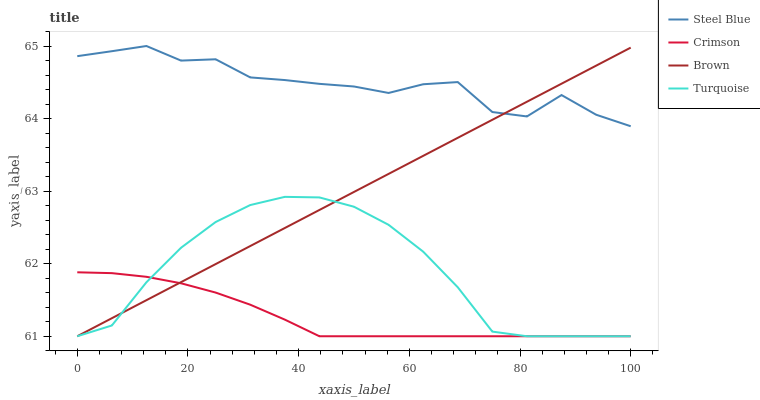Does Crimson have the minimum area under the curve?
Answer yes or no. Yes. Does Steel Blue have the maximum area under the curve?
Answer yes or no. Yes. Does Brown have the minimum area under the curve?
Answer yes or no. No. Does Brown have the maximum area under the curve?
Answer yes or no. No. Is Brown the smoothest?
Answer yes or no. Yes. Is Steel Blue the roughest?
Answer yes or no. Yes. Is Turquoise the smoothest?
Answer yes or no. No. Is Turquoise the roughest?
Answer yes or no. No. Does Crimson have the lowest value?
Answer yes or no. Yes. Does Steel Blue have the lowest value?
Answer yes or no. No. Does Steel Blue have the highest value?
Answer yes or no. Yes. Does Brown have the highest value?
Answer yes or no. No. Is Turquoise less than Steel Blue?
Answer yes or no. Yes. Is Steel Blue greater than Crimson?
Answer yes or no. Yes. Does Steel Blue intersect Brown?
Answer yes or no. Yes. Is Steel Blue less than Brown?
Answer yes or no. No. Is Steel Blue greater than Brown?
Answer yes or no. No. Does Turquoise intersect Steel Blue?
Answer yes or no. No. 